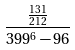<formula> <loc_0><loc_0><loc_500><loc_500>\frac { \frac { 1 3 1 } { 2 1 2 } } { 3 9 9 ^ { 6 } - 9 6 }</formula> 